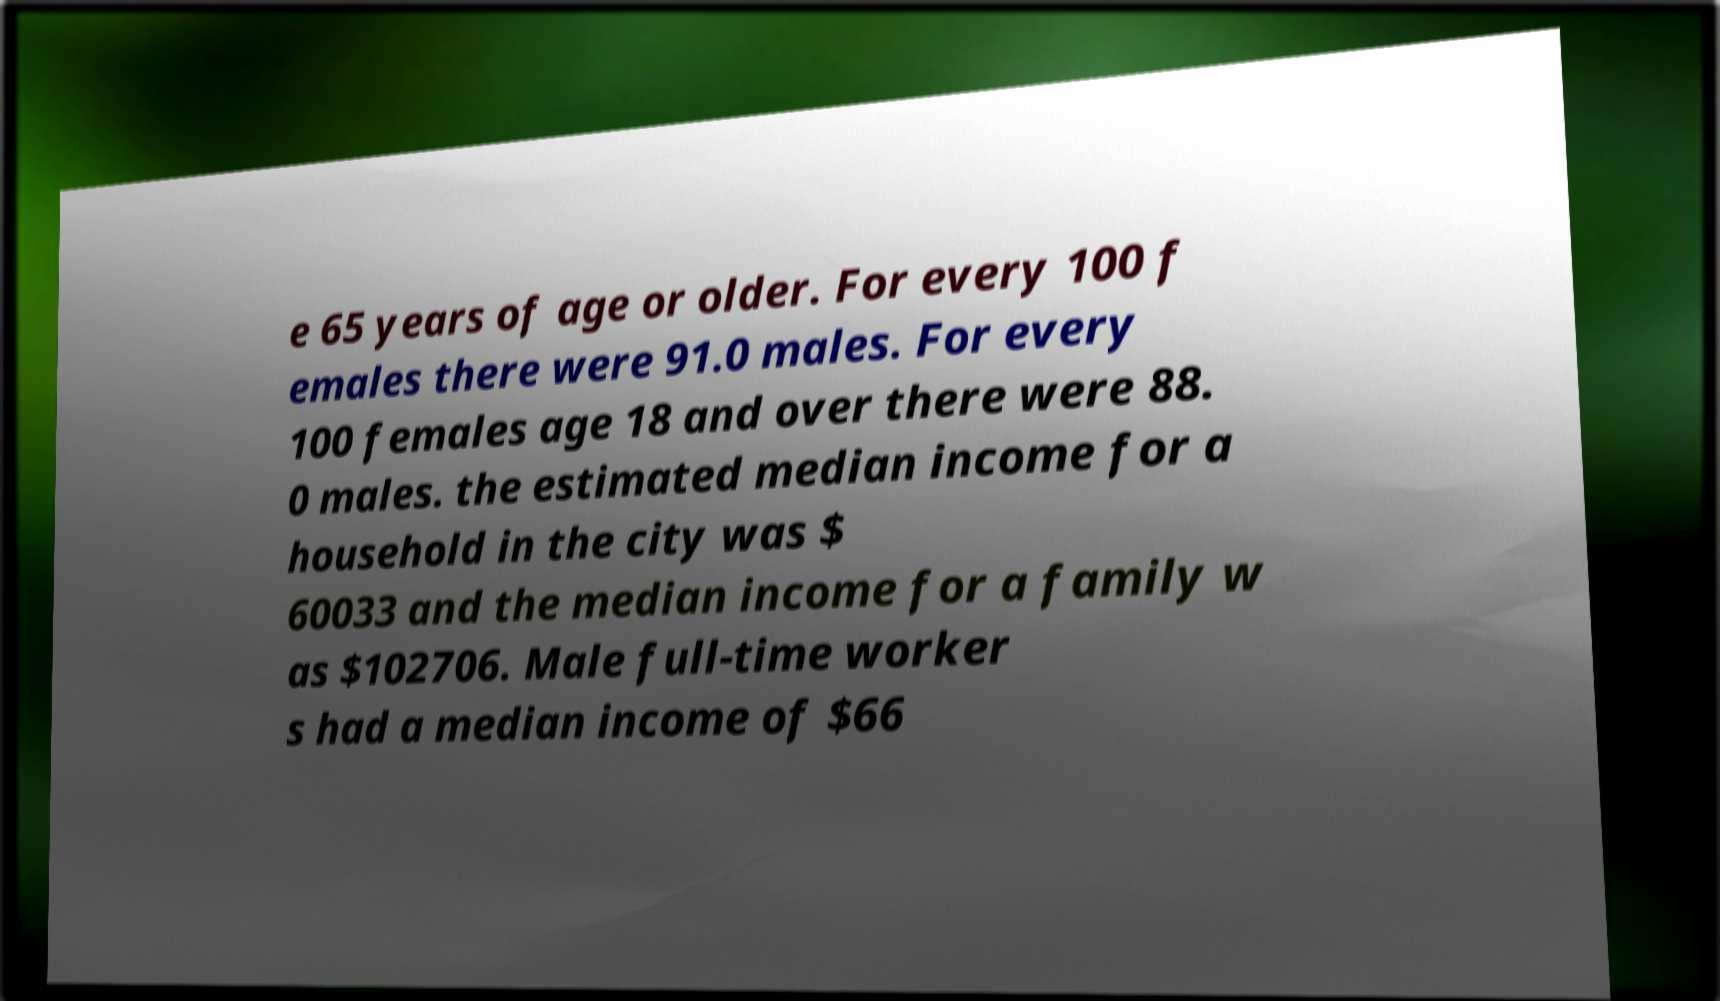Please identify and transcribe the text found in this image. e 65 years of age or older. For every 100 f emales there were 91.0 males. For every 100 females age 18 and over there were 88. 0 males. the estimated median income for a household in the city was $ 60033 and the median income for a family w as $102706. Male full-time worker s had a median income of $66 